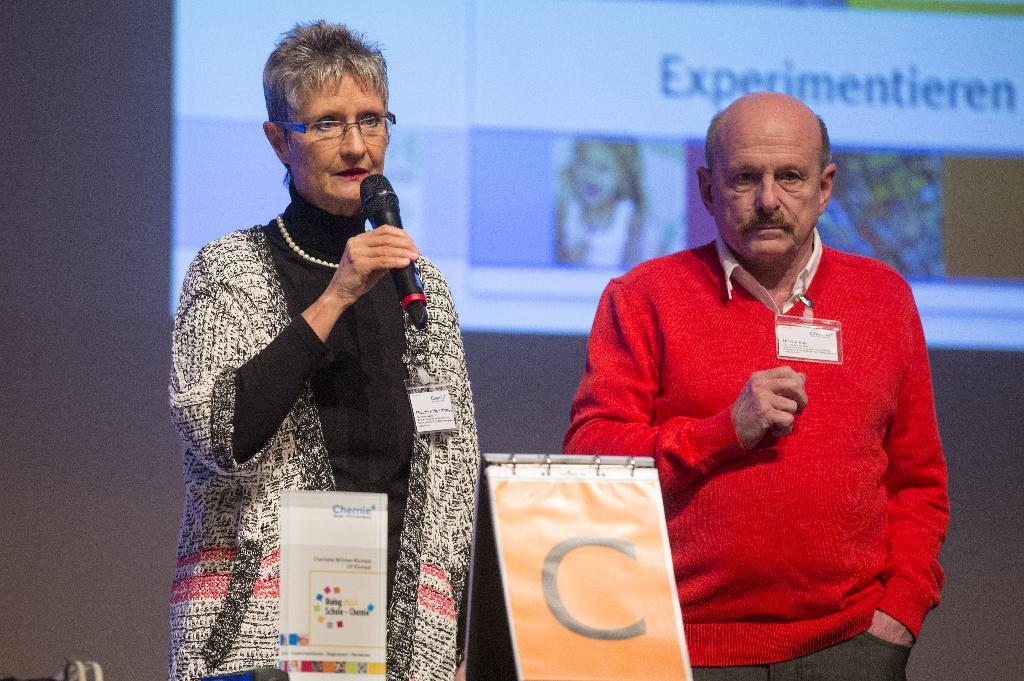How many people are in the image? There are two persons in the image. What is the woman holding in the image? The woman is holding a microphone. What is the man doing in the image? The man is standing. What can be seen in the background of the image? There is a screen in the background of the image. What type of scent can be detected from the image? There is no scent present in the image, as it is a visual representation. 